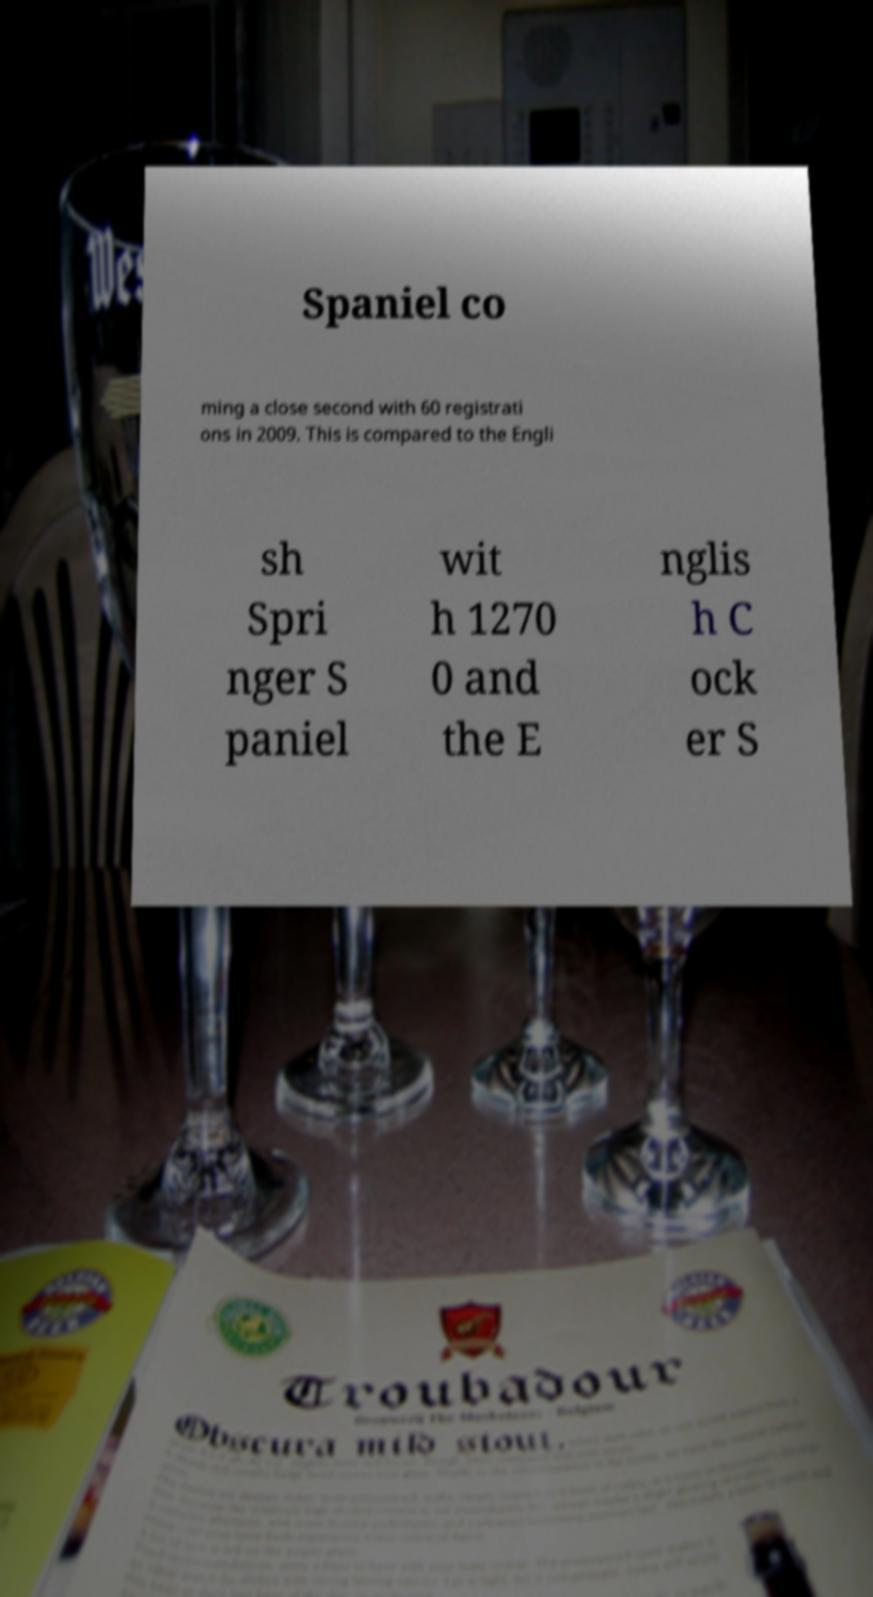Can you accurately transcribe the text from the provided image for me? Spaniel co ming a close second with 60 registrati ons in 2009. This is compared to the Engli sh Spri nger S paniel wit h 1270 0 and the E nglis h C ock er S 